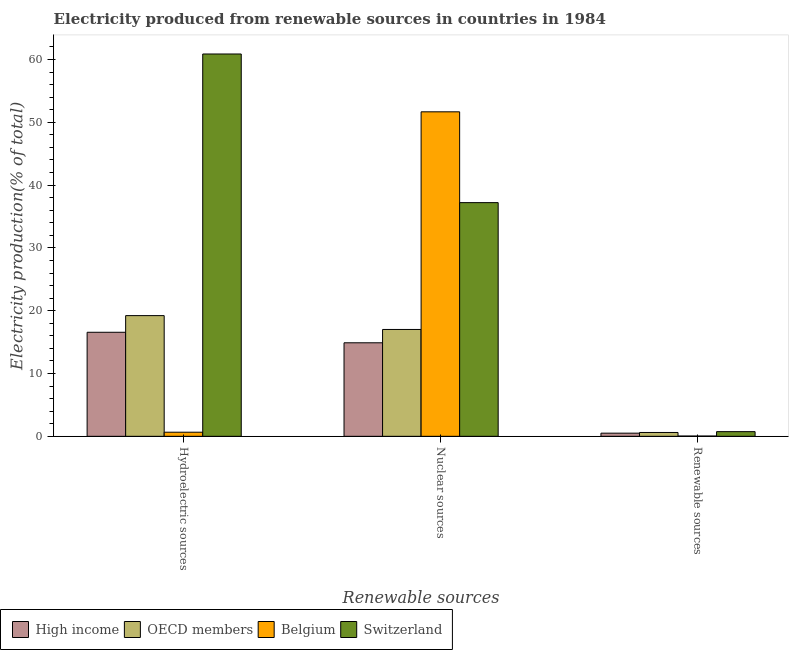How many groups of bars are there?
Offer a terse response. 3. Are the number of bars on each tick of the X-axis equal?
Give a very brief answer. Yes. How many bars are there on the 1st tick from the right?
Offer a terse response. 4. What is the label of the 3rd group of bars from the left?
Offer a very short reply. Renewable sources. What is the percentage of electricity produced by renewable sources in Belgium?
Keep it short and to the point. 0.04. Across all countries, what is the maximum percentage of electricity produced by renewable sources?
Keep it short and to the point. 0.74. Across all countries, what is the minimum percentage of electricity produced by nuclear sources?
Ensure brevity in your answer.  14.89. In which country was the percentage of electricity produced by renewable sources maximum?
Offer a terse response. Switzerland. In which country was the percentage of electricity produced by hydroelectric sources minimum?
Provide a succinct answer. Belgium. What is the total percentage of electricity produced by nuclear sources in the graph?
Your answer should be compact. 120.79. What is the difference between the percentage of electricity produced by nuclear sources in OECD members and that in High income?
Your response must be concise. 2.12. What is the difference between the percentage of electricity produced by hydroelectric sources in Switzerland and the percentage of electricity produced by nuclear sources in High income?
Make the answer very short. 45.99. What is the average percentage of electricity produced by hydroelectric sources per country?
Ensure brevity in your answer.  24.33. What is the difference between the percentage of electricity produced by renewable sources and percentage of electricity produced by hydroelectric sources in Belgium?
Provide a short and direct response. -0.61. In how many countries, is the percentage of electricity produced by nuclear sources greater than 20 %?
Make the answer very short. 2. What is the ratio of the percentage of electricity produced by renewable sources in High income to that in Switzerland?
Keep it short and to the point. 0.68. Is the difference between the percentage of electricity produced by renewable sources in High income and Switzerland greater than the difference between the percentage of electricity produced by hydroelectric sources in High income and Switzerland?
Ensure brevity in your answer.  Yes. What is the difference between the highest and the second highest percentage of electricity produced by nuclear sources?
Make the answer very short. 14.46. What is the difference between the highest and the lowest percentage of electricity produced by nuclear sources?
Offer a terse response. 36.78. What does the 1st bar from the right in Renewable sources represents?
Provide a short and direct response. Switzerland. Are all the bars in the graph horizontal?
Make the answer very short. No. Are the values on the major ticks of Y-axis written in scientific E-notation?
Provide a succinct answer. No. Does the graph contain any zero values?
Make the answer very short. No. Where does the legend appear in the graph?
Your answer should be very brief. Bottom left. How many legend labels are there?
Provide a succinct answer. 4. What is the title of the graph?
Make the answer very short. Electricity produced from renewable sources in countries in 1984. What is the label or title of the X-axis?
Your response must be concise. Renewable sources. What is the label or title of the Y-axis?
Your answer should be compact. Electricity production(% of total). What is the Electricity production(% of total) in High income in Hydroelectric sources?
Your answer should be very brief. 16.57. What is the Electricity production(% of total) in OECD members in Hydroelectric sources?
Ensure brevity in your answer.  19.22. What is the Electricity production(% of total) in Belgium in Hydroelectric sources?
Provide a succinct answer. 0.65. What is the Electricity production(% of total) in Switzerland in Hydroelectric sources?
Your answer should be compact. 60.88. What is the Electricity production(% of total) of High income in Nuclear sources?
Your answer should be very brief. 14.89. What is the Electricity production(% of total) of OECD members in Nuclear sources?
Your answer should be compact. 17.02. What is the Electricity production(% of total) of Belgium in Nuclear sources?
Give a very brief answer. 51.67. What is the Electricity production(% of total) in Switzerland in Nuclear sources?
Offer a terse response. 37.21. What is the Electricity production(% of total) in High income in Renewable sources?
Provide a short and direct response. 0.5. What is the Electricity production(% of total) in OECD members in Renewable sources?
Offer a terse response. 0.61. What is the Electricity production(% of total) of Belgium in Renewable sources?
Make the answer very short. 0.04. What is the Electricity production(% of total) in Switzerland in Renewable sources?
Your response must be concise. 0.74. Across all Renewable sources, what is the maximum Electricity production(% of total) in High income?
Your answer should be very brief. 16.57. Across all Renewable sources, what is the maximum Electricity production(% of total) in OECD members?
Make the answer very short. 19.22. Across all Renewable sources, what is the maximum Electricity production(% of total) of Belgium?
Offer a terse response. 51.67. Across all Renewable sources, what is the maximum Electricity production(% of total) in Switzerland?
Your answer should be compact. 60.88. Across all Renewable sources, what is the minimum Electricity production(% of total) of High income?
Provide a succinct answer. 0.5. Across all Renewable sources, what is the minimum Electricity production(% of total) in OECD members?
Offer a very short reply. 0.61. Across all Renewable sources, what is the minimum Electricity production(% of total) of Belgium?
Ensure brevity in your answer.  0.04. Across all Renewable sources, what is the minimum Electricity production(% of total) of Switzerland?
Provide a succinct answer. 0.74. What is the total Electricity production(% of total) of High income in the graph?
Your response must be concise. 31.96. What is the total Electricity production(% of total) in OECD members in the graph?
Keep it short and to the point. 36.85. What is the total Electricity production(% of total) in Belgium in the graph?
Give a very brief answer. 52.37. What is the total Electricity production(% of total) of Switzerland in the graph?
Your answer should be compact. 98.84. What is the difference between the Electricity production(% of total) of High income in Hydroelectric sources and that in Nuclear sources?
Offer a very short reply. 1.68. What is the difference between the Electricity production(% of total) of OECD members in Hydroelectric sources and that in Nuclear sources?
Offer a terse response. 2.2. What is the difference between the Electricity production(% of total) of Belgium in Hydroelectric sources and that in Nuclear sources?
Your response must be concise. -51.02. What is the difference between the Electricity production(% of total) of Switzerland in Hydroelectric sources and that in Nuclear sources?
Offer a terse response. 23.67. What is the difference between the Electricity production(% of total) of High income in Hydroelectric sources and that in Renewable sources?
Your answer should be compact. 16.06. What is the difference between the Electricity production(% of total) in OECD members in Hydroelectric sources and that in Renewable sources?
Give a very brief answer. 18.61. What is the difference between the Electricity production(% of total) of Belgium in Hydroelectric sources and that in Renewable sources?
Give a very brief answer. 0.61. What is the difference between the Electricity production(% of total) of Switzerland in Hydroelectric sources and that in Renewable sources?
Give a very brief answer. 60.14. What is the difference between the Electricity production(% of total) in High income in Nuclear sources and that in Renewable sources?
Provide a short and direct response. 14.39. What is the difference between the Electricity production(% of total) in OECD members in Nuclear sources and that in Renewable sources?
Offer a very short reply. 16.4. What is the difference between the Electricity production(% of total) in Belgium in Nuclear sources and that in Renewable sources?
Your answer should be very brief. 51.63. What is the difference between the Electricity production(% of total) of Switzerland in Nuclear sources and that in Renewable sources?
Provide a short and direct response. 36.47. What is the difference between the Electricity production(% of total) of High income in Hydroelectric sources and the Electricity production(% of total) of OECD members in Nuclear sources?
Give a very brief answer. -0.45. What is the difference between the Electricity production(% of total) of High income in Hydroelectric sources and the Electricity production(% of total) of Belgium in Nuclear sources?
Make the answer very short. -35.11. What is the difference between the Electricity production(% of total) in High income in Hydroelectric sources and the Electricity production(% of total) in Switzerland in Nuclear sources?
Offer a terse response. -20.64. What is the difference between the Electricity production(% of total) of OECD members in Hydroelectric sources and the Electricity production(% of total) of Belgium in Nuclear sources?
Ensure brevity in your answer.  -32.45. What is the difference between the Electricity production(% of total) in OECD members in Hydroelectric sources and the Electricity production(% of total) in Switzerland in Nuclear sources?
Provide a succinct answer. -17.99. What is the difference between the Electricity production(% of total) in Belgium in Hydroelectric sources and the Electricity production(% of total) in Switzerland in Nuclear sources?
Your answer should be compact. -36.56. What is the difference between the Electricity production(% of total) in High income in Hydroelectric sources and the Electricity production(% of total) in OECD members in Renewable sources?
Your answer should be compact. 15.96. What is the difference between the Electricity production(% of total) of High income in Hydroelectric sources and the Electricity production(% of total) of Belgium in Renewable sources?
Provide a succinct answer. 16.52. What is the difference between the Electricity production(% of total) of High income in Hydroelectric sources and the Electricity production(% of total) of Switzerland in Renewable sources?
Offer a very short reply. 15.82. What is the difference between the Electricity production(% of total) of OECD members in Hydroelectric sources and the Electricity production(% of total) of Belgium in Renewable sources?
Your response must be concise. 19.17. What is the difference between the Electricity production(% of total) of OECD members in Hydroelectric sources and the Electricity production(% of total) of Switzerland in Renewable sources?
Provide a succinct answer. 18.47. What is the difference between the Electricity production(% of total) of Belgium in Hydroelectric sources and the Electricity production(% of total) of Switzerland in Renewable sources?
Keep it short and to the point. -0.09. What is the difference between the Electricity production(% of total) in High income in Nuclear sources and the Electricity production(% of total) in OECD members in Renewable sources?
Provide a short and direct response. 14.28. What is the difference between the Electricity production(% of total) in High income in Nuclear sources and the Electricity production(% of total) in Belgium in Renewable sources?
Offer a terse response. 14.85. What is the difference between the Electricity production(% of total) of High income in Nuclear sources and the Electricity production(% of total) of Switzerland in Renewable sources?
Your response must be concise. 14.15. What is the difference between the Electricity production(% of total) of OECD members in Nuclear sources and the Electricity production(% of total) of Belgium in Renewable sources?
Your response must be concise. 16.97. What is the difference between the Electricity production(% of total) of OECD members in Nuclear sources and the Electricity production(% of total) of Switzerland in Renewable sources?
Ensure brevity in your answer.  16.27. What is the difference between the Electricity production(% of total) in Belgium in Nuclear sources and the Electricity production(% of total) in Switzerland in Renewable sources?
Keep it short and to the point. 50.93. What is the average Electricity production(% of total) in High income per Renewable sources?
Keep it short and to the point. 10.65. What is the average Electricity production(% of total) of OECD members per Renewable sources?
Make the answer very short. 12.28. What is the average Electricity production(% of total) in Belgium per Renewable sources?
Your answer should be compact. 17.46. What is the average Electricity production(% of total) in Switzerland per Renewable sources?
Provide a succinct answer. 32.95. What is the difference between the Electricity production(% of total) of High income and Electricity production(% of total) of OECD members in Hydroelectric sources?
Offer a very short reply. -2.65. What is the difference between the Electricity production(% of total) in High income and Electricity production(% of total) in Belgium in Hydroelectric sources?
Give a very brief answer. 15.91. What is the difference between the Electricity production(% of total) of High income and Electricity production(% of total) of Switzerland in Hydroelectric sources?
Your answer should be very brief. -44.31. What is the difference between the Electricity production(% of total) of OECD members and Electricity production(% of total) of Belgium in Hydroelectric sources?
Provide a succinct answer. 18.56. What is the difference between the Electricity production(% of total) of OECD members and Electricity production(% of total) of Switzerland in Hydroelectric sources?
Offer a very short reply. -41.66. What is the difference between the Electricity production(% of total) of Belgium and Electricity production(% of total) of Switzerland in Hydroelectric sources?
Your answer should be compact. -60.23. What is the difference between the Electricity production(% of total) in High income and Electricity production(% of total) in OECD members in Nuclear sources?
Ensure brevity in your answer.  -2.12. What is the difference between the Electricity production(% of total) in High income and Electricity production(% of total) in Belgium in Nuclear sources?
Offer a terse response. -36.78. What is the difference between the Electricity production(% of total) of High income and Electricity production(% of total) of Switzerland in Nuclear sources?
Provide a succinct answer. -22.32. What is the difference between the Electricity production(% of total) of OECD members and Electricity production(% of total) of Belgium in Nuclear sources?
Your response must be concise. -34.66. What is the difference between the Electricity production(% of total) of OECD members and Electricity production(% of total) of Switzerland in Nuclear sources?
Offer a terse response. -20.2. What is the difference between the Electricity production(% of total) in Belgium and Electricity production(% of total) in Switzerland in Nuclear sources?
Make the answer very short. 14.46. What is the difference between the Electricity production(% of total) in High income and Electricity production(% of total) in OECD members in Renewable sources?
Offer a terse response. -0.11. What is the difference between the Electricity production(% of total) in High income and Electricity production(% of total) in Belgium in Renewable sources?
Keep it short and to the point. 0.46. What is the difference between the Electricity production(% of total) of High income and Electricity production(% of total) of Switzerland in Renewable sources?
Your response must be concise. -0.24. What is the difference between the Electricity production(% of total) of OECD members and Electricity production(% of total) of Belgium in Renewable sources?
Provide a succinct answer. 0.57. What is the difference between the Electricity production(% of total) of OECD members and Electricity production(% of total) of Switzerland in Renewable sources?
Provide a succinct answer. -0.13. What is the difference between the Electricity production(% of total) in Belgium and Electricity production(% of total) in Switzerland in Renewable sources?
Make the answer very short. -0.7. What is the ratio of the Electricity production(% of total) in High income in Hydroelectric sources to that in Nuclear sources?
Offer a terse response. 1.11. What is the ratio of the Electricity production(% of total) of OECD members in Hydroelectric sources to that in Nuclear sources?
Your answer should be compact. 1.13. What is the ratio of the Electricity production(% of total) in Belgium in Hydroelectric sources to that in Nuclear sources?
Your answer should be compact. 0.01. What is the ratio of the Electricity production(% of total) in Switzerland in Hydroelectric sources to that in Nuclear sources?
Offer a very short reply. 1.64. What is the ratio of the Electricity production(% of total) of High income in Hydroelectric sources to that in Renewable sources?
Ensure brevity in your answer.  32.95. What is the ratio of the Electricity production(% of total) in OECD members in Hydroelectric sources to that in Renewable sources?
Your answer should be very brief. 31.44. What is the ratio of the Electricity production(% of total) of Belgium in Hydroelectric sources to that in Renewable sources?
Provide a succinct answer. 14.62. What is the ratio of the Electricity production(% of total) in Switzerland in Hydroelectric sources to that in Renewable sources?
Provide a succinct answer. 81.76. What is the ratio of the Electricity production(% of total) of High income in Nuclear sources to that in Renewable sources?
Provide a succinct answer. 29.62. What is the ratio of the Electricity production(% of total) in OECD members in Nuclear sources to that in Renewable sources?
Provide a short and direct response. 27.83. What is the ratio of the Electricity production(% of total) in Belgium in Nuclear sources to that in Renewable sources?
Your answer should be very brief. 1155.96. What is the ratio of the Electricity production(% of total) of Switzerland in Nuclear sources to that in Renewable sources?
Your answer should be compact. 49.97. What is the difference between the highest and the second highest Electricity production(% of total) in High income?
Offer a terse response. 1.68. What is the difference between the highest and the second highest Electricity production(% of total) of OECD members?
Keep it short and to the point. 2.2. What is the difference between the highest and the second highest Electricity production(% of total) of Belgium?
Offer a terse response. 51.02. What is the difference between the highest and the second highest Electricity production(% of total) in Switzerland?
Offer a terse response. 23.67. What is the difference between the highest and the lowest Electricity production(% of total) of High income?
Keep it short and to the point. 16.06. What is the difference between the highest and the lowest Electricity production(% of total) of OECD members?
Ensure brevity in your answer.  18.61. What is the difference between the highest and the lowest Electricity production(% of total) of Belgium?
Your answer should be very brief. 51.63. What is the difference between the highest and the lowest Electricity production(% of total) in Switzerland?
Offer a terse response. 60.14. 